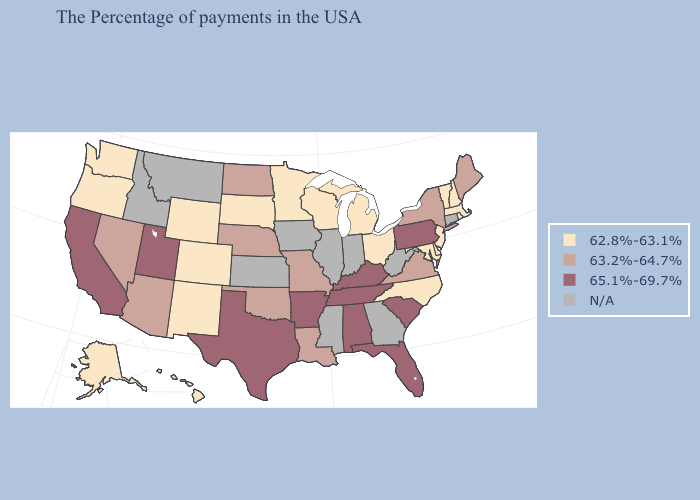What is the value of Oklahoma?
Be succinct. 63.2%-64.7%. Which states hav the highest value in the South?
Keep it brief. South Carolina, Florida, Kentucky, Alabama, Tennessee, Arkansas, Texas. What is the value of Florida?
Give a very brief answer. 65.1%-69.7%. Which states have the lowest value in the Northeast?
Answer briefly. Massachusetts, Rhode Island, New Hampshire, Vermont, New Jersey. Among the states that border Maine , which have the highest value?
Quick response, please. New Hampshire. Name the states that have a value in the range N/A?
Give a very brief answer. Connecticut, West Virginia, Georgia, Indiana, Illinois, Mississippi, Iowa, Kansas, Montana, Idaho. Name the states that have a value in the range 63.2%-64.7%?
Quick response, please. Maine, New York, Virginia, Louisiana, Missouri, Nebraska, Oklahoma, North Dakota, Arizona, Nevada. Name the states that have a value in the range 63.2%-64.7%?
Short answer required. Maine, New York, Virginia, Louisiana, Missouri, Nebraska, Oklahoma, North Dakota, Arizona, Nevada. Name the states that have a value in the range N/A?
Be succinct. Connecticut, West Virginia, Georgia, Indiana, Illinois, Mississippi, Iowa, Kansas, Montana, Idaho. Among the states that border Utah , does New Mexico have the lowest value?
Short answer required. Yes. Among the states that border Texas , does Arkansas have the lowest value?
Give a very brief answer. No. What is the value of Connecticut?
Quick response, please. N/A. Among the states that border Connecticut , which have the highest value?
Answer briefly. New York. Which states hav the highest value in the West?
Short answer required. Utah, California. Among the states that border California , does Arizona have the highest value?
Quick response, please. Yes. 